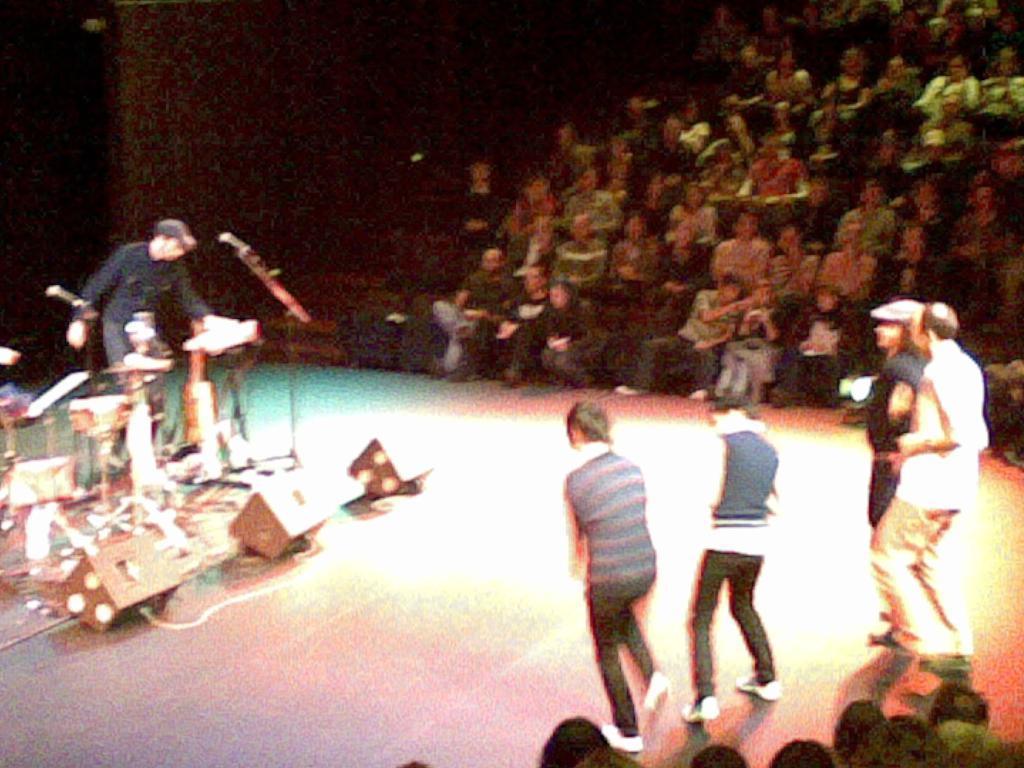In one or two sentences, can you explain what this image depicts? In the foreground of this image, there are four persons standing on the stage on the right side. On the bottom, there are heads of the person. On the left, there is a man standing and there are musical instruments in front of him and there are tree lights on the stage. In the background, there is the crowd sitting and the stairs. 